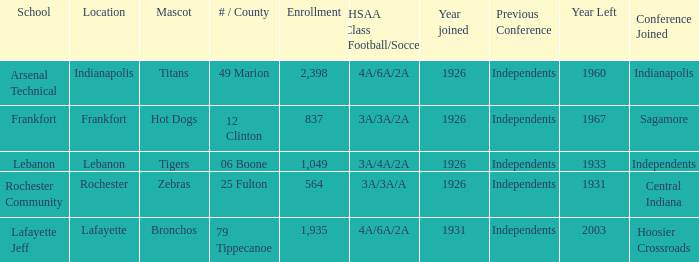What is the minimum enrollment count for lafayette as the venue? 1935.0. 